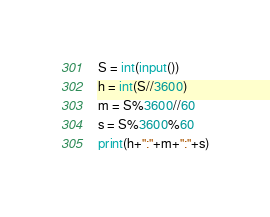<code> <loc_0><loc_0><loc_500><loc_500><_Python_>S = int(input())
h = int(S//3600)
m = S%3600//60
s = S%3600%60
print(h+":"+m+":"+s)</code> 